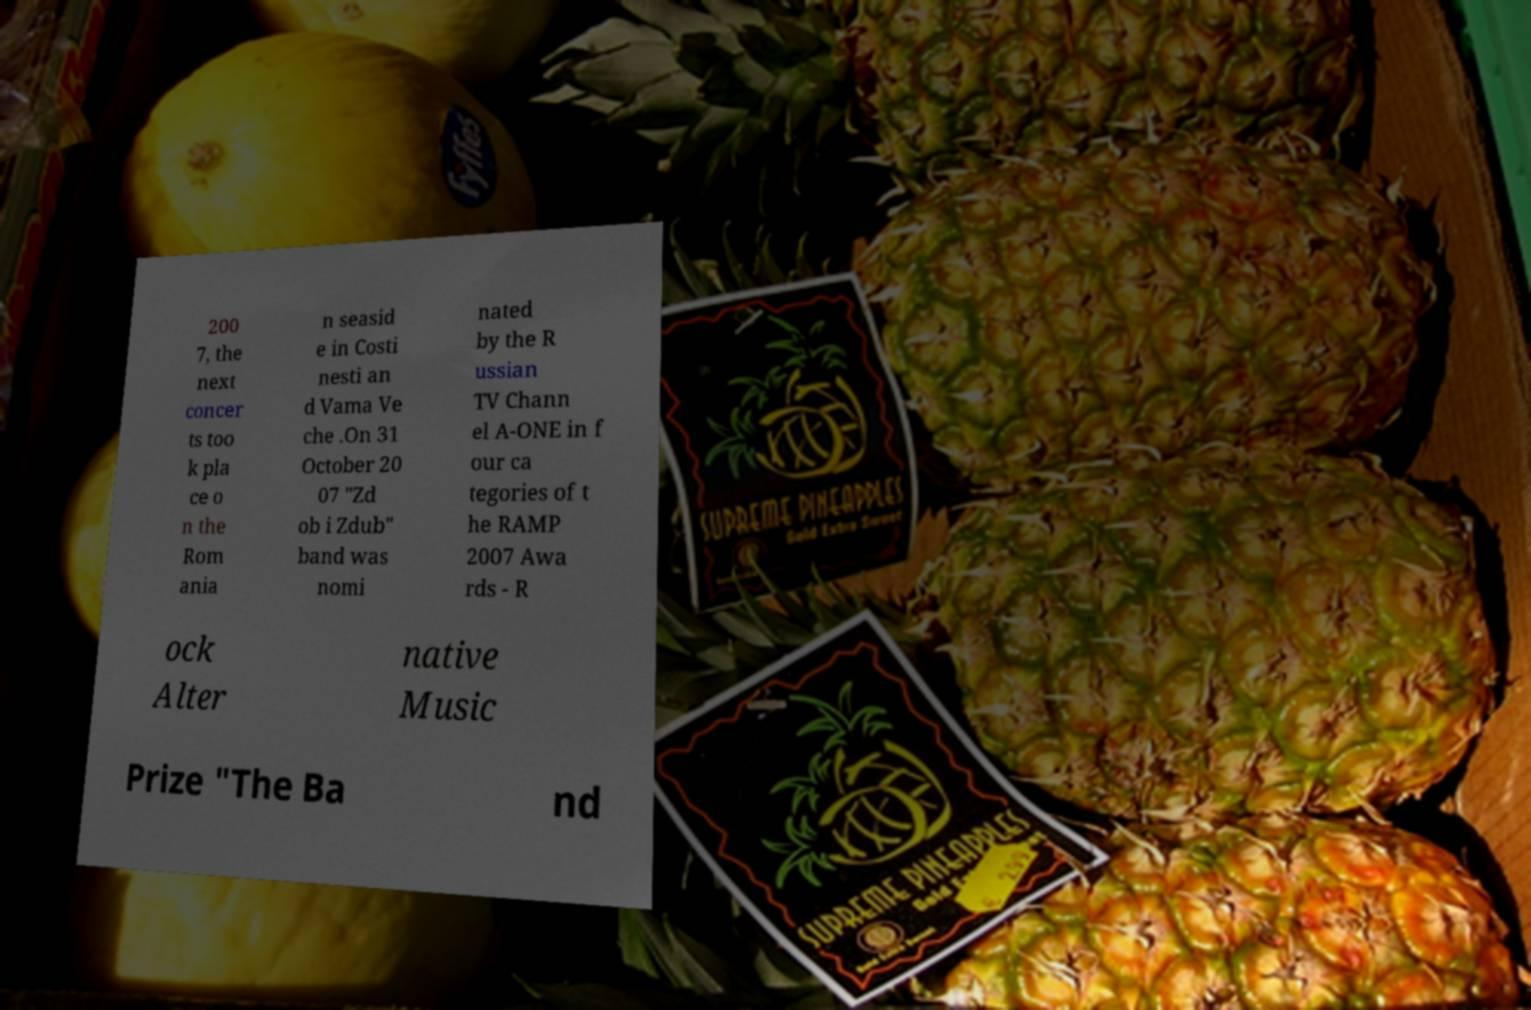Could you assist in decoding the text presented in this image and type it out clearly? 200 7, the next concer ts too k pla ce o n the Rom ania n seasid e in Costi nesti an d Vama Ve che .On 31 October 20 07 "Zd ob i Zdub" band was nomi nated by the R ussian TV Chann el A-ONE in f our ca tegories of t he RAMP 2007 Awa rds - R ock Alter native Music Prize "The Ba nd 